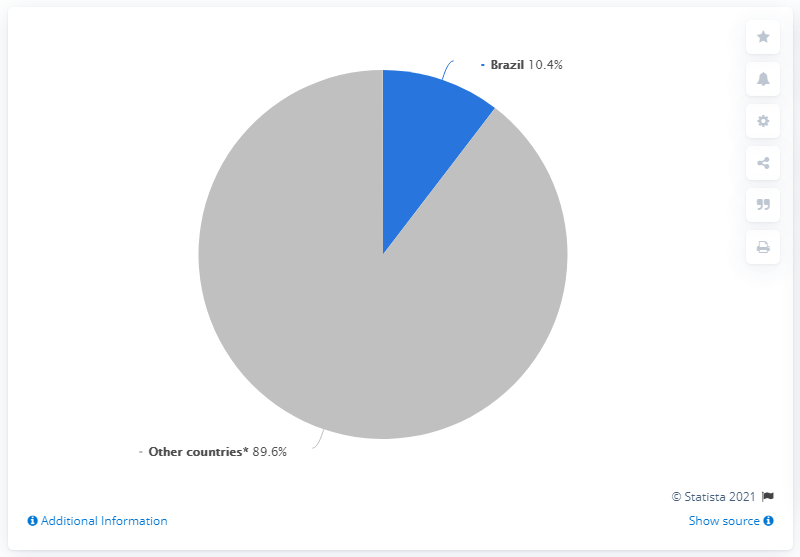Indicate a few pertinent items in this graphic. Brazil is being compared to other countries. Brazil differs from other countries in terms of its 79.2% literacy rate. Brazil had the most downloads of the TikTok app in January 2020. 